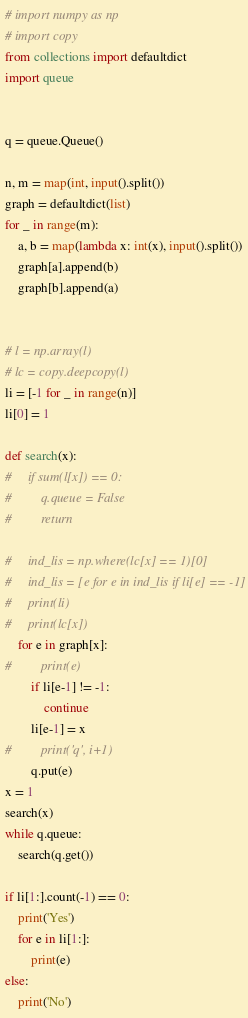<code> <loc_0><loc_0><loc_500><loc_500><_Python_># import numpy as np
# import copy
from collections import defaultdict
import queue


q = queue.Queue()

n, m = map(int, input().split())
graph = defaultdict(list)
for _ in range(m):
    a, b = map(lambda x: int(x), input().split())
    graph[a].append(b)
    graph[b].append(a)


# l = np.array(l)
# lc = copy.deepcopy(l)
li = [-1 for _ in range(n)]
li[0] = 1

def search(x):
#     if sum(l[x]) == 0:
#         q.queue = False
#         return
    
#     ind_lis = np.where(lc[x] == 1)[0]
#     ind_lis = [e for e in ind_lis if li[e] == -1]
#     print(li)
#     print(lc[x])
    for e in graph[x]:
#         print(e)
        if li[e-1] != -1:
            continue
        li[e-1] = x
#         print('q', i+1)
        q.put(e)
x = 1
search(x)
while q.queue:
    search(q.get())

if li[1:].count(-1) == 0:
    print('Yes')
    for e in li[1:]:
        print(e)
else:
    print('No')
</code> 